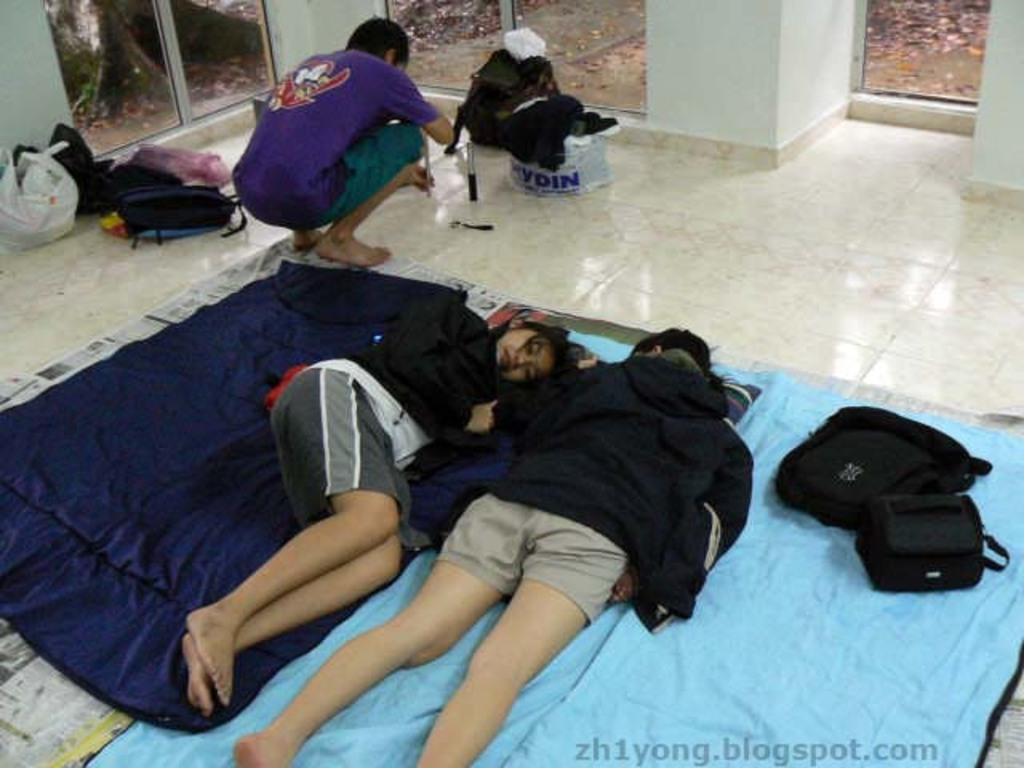<image>
Offer a succinct explanation of the picture presented. A post for zh1yong.blogspot.com showing people laying on blankets on the floor of a room. 